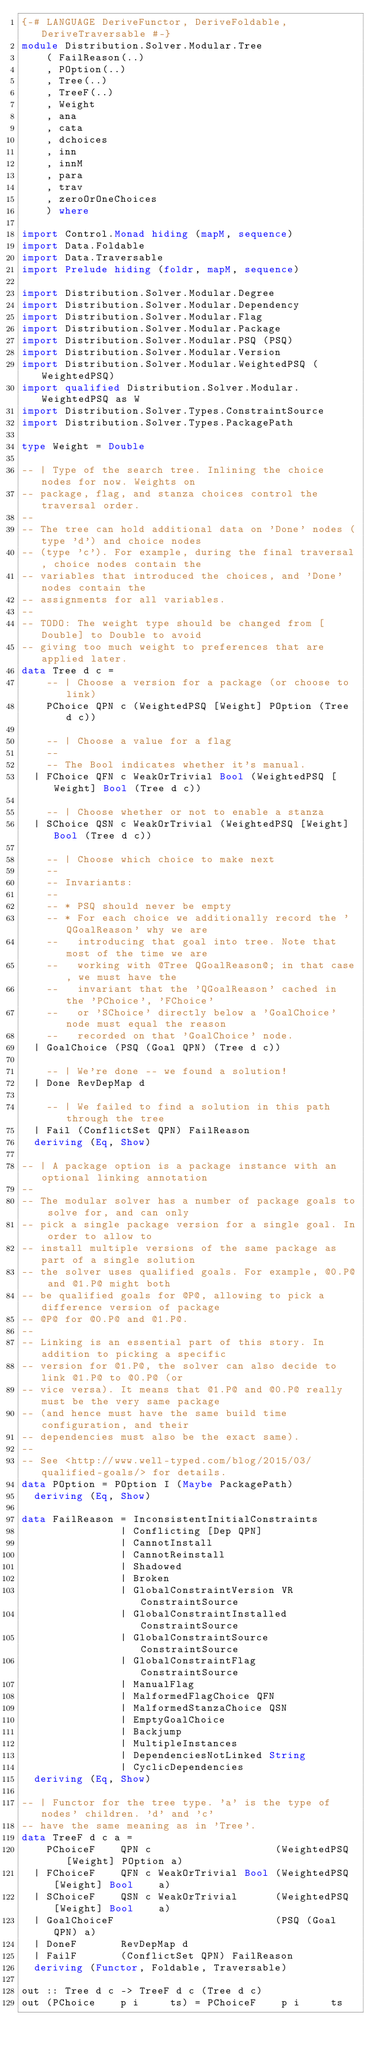<code> <loc_0><loc_0><loc_500><loc_500><_Haskell_>{-# LANGUAGE DeriveFunctor, DeriveFoldable, DeriveTraversable #-}
module Distribution.Solver.Modular.Tree
    ( FailReason(..)
    , POption(..)
    , Tree(..)
    , TreeF(..)
    , Weight
    , ana
    , cata
    , dchoices
    , inn
    , innM
    , para
    , trav
    , zeroOrOneChoices
    ) where

import Control.Monad hiding (mapM, sequence)
import Data.Foldable
import Data.Traversable
import Prelude hiding (foldr, mapM, sequence)

import Distribution.Solver.Modular.Degree
import Distribution.Solver.Modular.Dependency
import Distribution.Solver.Modular.Flag
import Distribution.Solver.Modular.Package
import Distribution.Solver.Modular.PSQ (PSQ)
import Distribution.Solver.Modular.Version
import Distribution.Solver.Modular.WeightedPSQ (WeightedPSQ)
import qualified Distribution.Solver.Modular.WeightedPSQ as W
import Distribution.Solver.Types.ConstraintSource
import Distribution.Solver.Types.PackagePath

type Weight = Double

-- | Type of the search tree. Inlining the choice nodes for now. Weights on
-- package, flag, and stanza choices control the traversal order.
--
-- The tree can hold additional data on 'Done' nodes (type 'd') and choice nodes
-- (type 'c'). For example, during the final traversal, choice nodes contain the
-- variables that introduced the choices, and 'Done' nodes contain the
-- assignments for all variables.
--
-- TODO: The weight type should be changed from [Double] to Double to avoid
-- giving too much weight to preferences that are applied later.
data Tree d c =
    -- | Choose a version for a package (or choose to link)
    PChoice QPN c (WeightedPSQ [Weight] POption (Tree d c))

    -- | Choose a value for a flag
    --
    -- The Bool indicates whether it's manual.
  | FChoice QFN c WeakOrTrivial Bool (WeightedPSQ [Weight] Bool (Tree d c))

    -- | Choose whether or not to enable a stanza
  | SChoice QSN c WeakOrTrivial (WeightedPSQ [Weight] Bool (Tree d c))

    -- | Choose which choice to make next
    --
    -- Invariants:
    --
    -- * PSQ should never be empty
    -- * For each choice we additionally record the 'QGoalReason' why we are
    --   introducing that goal into tree. Note that most of the time we are
    --   working with @Tree QGoalReason@; in that case, we must have the
    --   invariant that the 'QGoalReason' cached in the 'PChoice', 'FChoice'
    --   or 'SChoice' directly below a 'GoalChoice' node must equal the reason
    --   recorded on that 'GoalChoice' node.
  | GoalChoice (PSQ (Goal QPN) (Tree d c))

    -- | We're done -- we found a solution!
  | Done RevDepMap d

    -- | We failed to find a solution in this path through the tree
  | Fail (ConflictSet QPN) FailReason
  deriving (Eq, Show)

-- | A package option is a package instance with an optional linking annotation
--
-- The modular solver has a number of package goals to solve for, and can only
-- pick a single package version for a single goal. In order to allow to
-- install multiple versions of the same package as part of a single solution
-- the solver uses qualified goals. For example, @0.P@ and @1.P@ might both
-- be qualified goals for @P@, allowing to pick a difference version of package
-- @P@ for @0.P@ and @1.P@.
--
-- Linking is an essential part of this story. In addition to picking a specific
-- version for @1.P@, the solver can also decide to link @1.P@ to @0.P@ (or
-- vice versa). It means that @1.P@ and @0.P@ really must be the very same package
-- (and hence must have the same build time configuration, and their
-- dependencies must also be the exact same).
--
-- See <http://www.well-typed.com/blog/2015/03/qualified-goals/> for details.
data POption = POption I (Maybe PackagePath)
  deriving (Eq, Show)

data FailReason = InconsistentInitialConstraints
                | Conflicting [Dep QPN]
                | CannotInstall
                | CannotReinstall
                | Shadowed
                | Broken
                | GlobalConstraintVersion VR ConstraintSource
                | GlobalConstraintInstalled ConstraintSource
                | GlobalConstraintSource ConstraintSource
                | GlobalConstraintFlag ConstraintSource
                | ManualFlag
                | MalformedFlagChoice QFN
                | MalformedStanzaChoice QSN
                | EmptyGoalChoice
                | Backjump
                | MultipleInstances
                | DependenciesNotLinked String
                | CyclicDependencies
  deriving (Eq, Show)

-- | Functor for the tree type. 'a' is the type of nodes' children. 'd' and 'c'
-- have the same meaning as in 'Tree'.
data TreeF d c a =
    PChoiceF    QPN c                    (WeightedPSQ [Weight] POption a)
  | FChoiceF    QFN c WeakOrTrivial Bool (WeightedPSQ [Weight] Bool    a)
  | SChoiceF    QSN c WeakOrTrivial      (WeightedPSQ [Weight] Bool    a)
  | GoalChoiceF                          (PSQ (Goal QPN) a)
  | DoneF       RevDepMap d
  | FailF       (ConflictSet QPN) FailReason
  deriving (Functor, Foldable, Traversable)

out :: Tree d c -> TreeF d c (Tree d c)
out (PChoice    p i     ts) = PChoiceF    p i     ts</code> 